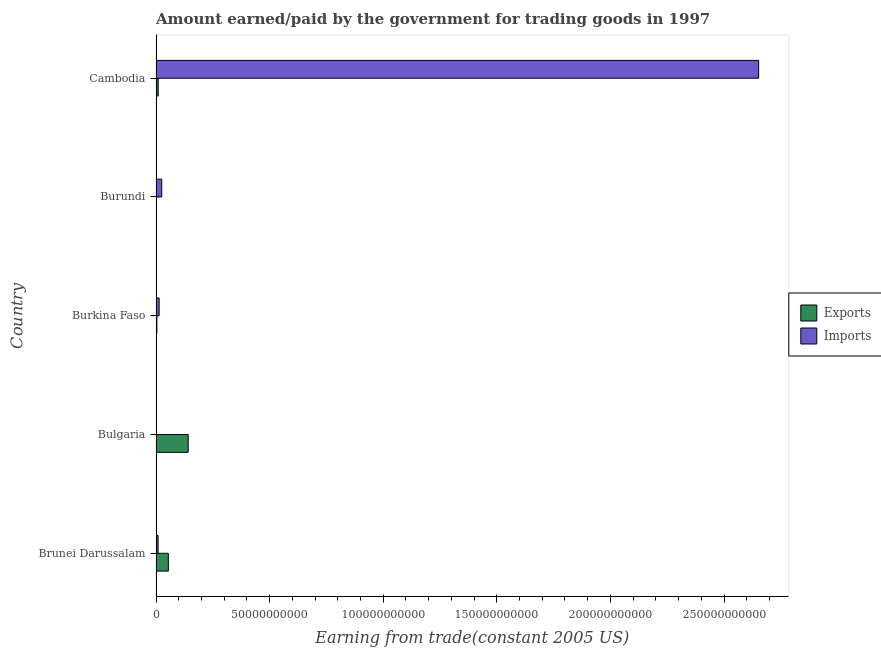How many different coloured bars are there?
Your answer should be very brief. 2. Are the number of bars on each tick of the Y-axis equal?
Give a very brief answer. Yes. What is the label of the 1st group of bars from the top?
Offer a terse response. Cambodia. What is the amount paid for imports in Brunei Darussalam?
Ensure brevity in your answer.  9.15e+08. Across all countries, what is the maximum amount paid for imports?
Your answer should be compact. 2.65e+11. Across all countries, what is the minimum amount paid for imports?
Offer a very short reply. 6.62e+07. In which country was the amount paid for imports maximum?
Make the answer very short. Cambodia. In which country was the amount earned from exports minimum?
Give a very brief answer. Burundi. What is the total amount paid for imports in the graph?
Offer a terse response. 2.70e+11. What is the difference between the amount earned from exports in Brunei Darussalam and that in Bulgaria?
Provide a short and direct response. -8.73e+09. What is the difference between the amount paid for imports in Burundi and the amount earned from exports in Brunei Darussalam?
Offer a terse response. -2.90e+09. What is the average amount paid for imports per country?
Keep it short and to the point. 5.40e+1. What is the difference between the amount earned from exports and amount paid for imports in Cambodia?
Your answer should be very brief. -2.64e+11. What is the ratio of the amount earned from exports in Burkina Faso to that in Burundi?
Give a very brief answer. 6.64. Is the amount paid for imports in Burundi less than that in Cambodia?
Offer a very short reply. Yes. Is the difference between the amount earned from exports in Bulgaria and Cambodia greater than the difference between the amount paid for imports in Bulgaria and Cambodia?
Offer a terse response. Yes. What is the difference between the highest and the second highest amount paid for imports?
Give a very brief answer. 2.63e+11. What is the difference between the highest and the lowest amount earned from exports?
Keep it short and to the point. 1.41e+1. Is the sum of the amount paid for imports in Bulgaria and Burkina Faso greater than the maximum amount earned from exports across all countries?
Keep it short and to the point. No. What does the 2nd bar from the top in Burkina Faso represents?
Give a very brief answer. Exports. What does the 2nd bar from the bottom in Burkina Faso represents?
Give a very brief answer. Imports. Are all the bars in the graph horizontal?
Your answer should be very brief. Yes. Does the graph contain any zero values?
Make the answer very short. No. How are the legend labels stacked?
Offer a terse response. Vertical. What is the title of the graph?
Your answer should be compact. Amount earned/paid by the government for trading goods in 1997. Does "Private credit bureau" appear as one of the legend labels in the graph?
Make the answer very short. No. What is the label or title of the X-axis?
Your answer should be compact. Earning from trade(constant 2005 US). What is the label or title of the Y-axis?
Provide a succinct answer. Country. What is the Earning from trade(constant 2005 US) in Exports in Brunei Darussalam?
Ensure brevity in your answer.  5.42e+09. What is the Earning from trade(constant 2005 US) of Imports in Brunei Darussalam?
Provide a short and direct response. 9.15e+08. What is the Earning from trade(constant 2005 US) of Exports in Bulgaria?
Provide a succinct answer. 1.42e+1. What is the Earning from trade(constant 2005 US) in Imports in Bulgaria?
Provide a short and direct response. 6.62e+07. What is the Earning from trade(constant 2005 US) of Exports in Burkina Faso?
Ensure brevity in your answer.  3.68e+08. What is the Earning from trade(constant 2005 US) in Imports in Burkina Faso?
Keep it short and to the point. 1.36e+09. What is the Earning from trade(constant 2005 US) of Exports in Burundi?
Your answer should be compact. 5.54e+07. What is the Earning from trade(constant 2005 US) in Imports in Burundi?
Your answer should be compact. 2.52e+09. What is the Earning from trade(constant 2005 US) of Exports in Cambodia?
Give a very brief answer. 9.76e+08. What is the Earning from trade(constant 2005 US) in Imports in Cambodia?
Your answer should be compact. 2.65e+11. Across all countries, what is the maximum Earning from trade(constant 2005 US) in Exports?
Keep it short and to the point. 1.42e+1. Across all countries, what is the maximum Earning from trade(constant 2005 US) in Imports?
Ensure brevity in your answer.  2.65e+11. Across all countries, what is the minimum Earning from trade(constant 2005 US) of Exports?
Your response must be concise. 5.54e+07. Across all countries, what is the minimum Earning from trade(constant 2005 US) of Imports?
Offer a very short reply. 6.62e+07. What is the total Earning from trade(constant 2005 US) in Exports in the graph?
Provide a succinct answer. 2.10e+1. What is the total Earning from trade(constant 2005 US) in Imports in the graph?
Keep it short and to the point. 2.70e+11. What is the difference between the Earning from trade(constant 2005 US) in Exports in Brunei Darussalam and that in Bulgaria?
Give a very brief answer. -8.73e+09. What is the difference between the Earning from trade(constant 2005 US) of Imports in Brunei Darussalam and that in Bulgaria?
Your answer should be very brief. 8.48e+08. What is the difference between the Earning from trade(constant 2005 US) of Exports in Brunei Darussalam and that in Burkina Faso?
Offer a terse response. 5.05e+09. What is the difference between the Earning from trade(constant 2005 US) of Imports in Brunei Darussalam and that in Burkina Faso?
Your answer should be very brief. -4.49e+08. What is the difference between the Earning from trade(constant 2005 US) in Exports in Brunei Darussalam and that in Burundi?
Provide a short and direct response. 5.37e+09. What is the difference between the Earning from trade(constant 2005 US) of Imports in Brunei Darussalam and that in Burundi?
Give a very brief answer. -1.60e+09. What is the difference between the Earning from trade(constant 2005 US) of Exports in Brunei Darussalam and that in Cambodia?
Your response must be concise. 4.45e+09. What is the difference between the Earning from trade(constant 2005 US) of Imports in Brunei Darussalam and that in Cambodia?
Keep it short and to the point. -2.64e+11. What is the difference between the Earning from trade(constant 2005 US) in Exports in Bulgaria and that in Burkina Faso?
Your answer should be very brief. 1.38e+1. What is the difference between the Earning from trade(constant 2005 US) of Imports in Bulgaria and that in Burkina Faso?
Keep it short and to the point. -1.30e+09. What is the difference between the Earning from trade(constant 2005 US) in Exports in Bulgaria and that in Burundi?
Make the answer very short. 1.41e+1. What is the difference between the Earning from trade(constant 2005 US) of Imports in Bulgaria and that in Burundi?
Provide a short and direct response. -2.45e+09. What is the difference between the Earning from trade(constant 2005 US) of Exports in Bulgaria and that in Cambodia?
Offer a terse response. 1.32e+1. What is the difference between the Earning from trade(constant 2005 US) in Imports in Bulgaria and that in Cambodia?
Your answer should be compact. -2.65e+11. What is the difference between the Earning from trade(constant 2005 US) of Exports in Burkina Faso and that in Burundi?
Your answer should be very brief. 3.12e+08. What is the difference between the Earning from trade(constant 2005 US) of Imports in Burkina Faso and that in Burundi?
Your answer should be compact. -1.16e+09. What is the difference between the Earning from trade(constant 2005 US) of Exports in Burkina Faso and that in Cambodia?
Provide a short and direct response. -6.09e+08. What is the difference between the Earning from trade(constant 2005 US) in Imports in Burkina Faso and that in Cambodia?
Your response must be concise. -2.64e+11. What is the difference between the Earning from trade(constant 2005 US) of Exports in Burundi and that in Cambodia?
Make the answer very short. -9.21e+08. What is the difference between the Earning from trade(constant 2005 US) of Imports in Burundi and that in Cambodia?
Provide a succinct answer. -2.63e+11. What is the difference between the Earning from trade(constant 2005 US) of Exports in Brunei Darussalam and the Earning from trade(constant 2005 US) of Imports in Bulgaria?
Give a very brief answer. 5.36e+09. What is the difference between the Earning from trade(constant 2005 US) in Exports in Brunei Darussalam and the Earning from trade(constant 2005 US) in Imports in Burkina Faso?
Your answer should be very brief. 4.06e+09. What is the difference between the Earning from trade(constant 2005 US) of Exports in Brunei Darussalam and the Earning from trade(constant 2005 US) of Imports in Burundi?
Keep it short and to the point. 2.90e+09. What is the difference between the Earning from trade(constant 2005 US) in Exports in Brunei Darussalam and the Earning from trade(constant 2005 US) in Imports in Cambodia?
Your answer should be very brief. -2.60e+11. What is the difference between the Earning from trade(constant 2005 US) of Exports in Bulgaria and the Earning from trade(constant 2005 US) of Imports in Burkina Faso?
Offer a terse response. 1.28e+1. What is the difference between the Earning from trade(constant 2005 US) in Exports in Bulgaria and the Earning from trade(constant 2005 US) in Imports in Burundi?
Give a very brief answer. 1.16e+1. What is the difference between the Earning from trade(constant 2005 US) in Exports in Bulgaria and the Earning from trade(constant 2005 US) in Imports in Cambodia?
Your response must be concise. -2.51e+11. What is the difference between the Earning from trade(constant 2005 US) in Exports in Burkina Faso and the Earning from trade(constant 2005 US) in Imports in Burundi?
Your answer should be very brief. -2.15e+09. What is the difference between the Earning from trade(constant 2005 US) of Exports in Burkina Faso and the Earning from trade(constant 2005 US) of Imports in Cambodia?
Your answer should be compact. -2.65e+11. What is the difference between the Earning from trade(constant 2005 US) in Exports in Burundi and the Earning from trade(constant 2005 US) in Imports in Cambodia?
Make the answer very short. -2.65e+11. What is the average Earning from trade(constant 2005 US) of Exports per country?
Give a very brief answer. 4.20e+09. What is the average Earning from trade(constant 2005 US) in Imports per country?
Offer a terse response. 5.40e+1. What is the difference between the Earning from trade(constant 2005 US) in Exports and Earning from trade(constant 2005 US) in Imports in Brunei Darussalam?
Provide a short and direct response. 4.51e+09. What is the difference between the Earning from trade(constant 2005 US) of Exports and Earning from trade(constant 2005 US) of Imports in Bulgaria?
Offer a very short reply. 1.41e+1. What is the difference between the Earning from trade(constant 2005 US) of Exports and Earning from trade(constant 2005 US) of Imports in Burkina Faso?
Offer a very short reply. -9.96e+08. What is the difference between the Earning from trade(constant 2005 US) of Exports and Earning from trade(constant 2005 US) of Imports in Burundi?
Your response must be concise. -2.46e+09. What is the difference between the Earning from trade(constant 2005 US) of Exports and Earning from trade(constant 2005 US) of Imports in Cambodia?
Keep it short and to the point. -2.64e+11. What is the ratio of the Earning from trade(constant 2005 US) in Exports in Brunei Darussalam to that in Bulgaria?
Offer a terse response. 0.38. What is the ratio of the Earning from trade(constant 2005 US) of Imports in Brunei Darussalam to that in Bulgaria?
Offer a very short reply. 13.82. What is the ratio of the Earning from trade(constant 2005 US) of Exports in Brunei Darussalam to that in Burkina Faso?
Offer a very short reply. 14.75. What is the ratio of the Earning from trade(constant 2005 US) in Imports in Brunei Darussalam to that in Burkina Faso?
Your answer should be compact. 0.67. What is the ratio of the Earning from trade(constant 2005 US) in Exports in Brunei Darussalam to that in Burundi?
Provide a succinct answer. 97.91. What is the ratio of the Earning from trade(constant 2005 US) in Imports in Brunei Darussalam to that in Burundi?
Give a very brief answer. 0.36. What is the ratio of the Earning from trade(constant 2005 US) in Exports in Brunei Darussalam to that in Cambodia?
Keep it short and to the point. 5.55. What is the ratio of the Earning from trade(constant 2005 US) in Imports in Brunei Darussalam to that in Cambodia?
Offer a very short reply. 0. What is the ratio of the Earning from trade(constant 2005 US) of Exports in Bulgaria to that in Burkina Faso?
Offer a very short reply. 38.52. What is the ratio of the Earning from trade(constant 2005 US) of Imports in Bulgaria to that in Burkina Faso?
Your response must be concise. 0.05. What is the ratio of the Earning from trade(constant 2005 US) of Exports in Bulgaria to that in Burundi?
Ensure brevity in your answer.  255.62. What is the ratio of the Earning from trade(constant 2005 US) of Imports in Bulgaria to that in Burundi?
Your answer should be very brief. 0.03. What is the ratio of the Earning from trade(constant 2005 US) in Exports in Bulgaria to that in Cambodia?
Provide a succinct answer. 14.5. What is the ratio of the Earning from trade(constant 2005 US) in Imports in Bulgaria to that in Cambodia?
Your answer should be very brief. 0. What is the ratio of the Earning from trade(constant 2005 US) in Exports in Burkina Faso to that in Burundi?
Offer a terse response. 6.64. What is the ratio of the Earning from trade(constant 2005 US) in Imports in Burkina Faso to that in Burundi?
Your answer should be very brief. 0.54. What is the ratio of the Earning from trade(constant 2005 US) in Exports in Burkina Faso to that in Cambodia?
Ensure brevity in your answer.  0.38. What is the ratio of the Earning from trade(constant 2005 US) in Imports in Burkina Faso to that in Cambodia?
Your answer should be compact. 0.01. What is the ratio of the Earning from trade(constant 2005 US) of Exports in Burundi to that in Cambodia?
Offer a terse response. 0.06. What is the ratio of the Earning from trade(constant 2005 US) in Imports in Burundi to that in Cambodia?
Provide a succinct answer. 0.01. What is the difference between the highest and the second highest Earning from trade(constant 2005 US) of Exports?
Ensure brevity in your answer.  8.73e+09. What is the difference between the highest and the second highest Earning from trade(constant 2005 US) of Imports?
Provide a short and direct response. 2.63e+11. What is the difference between the highest and the lowest Earning from trade(constant 2005 US) of Exports?
Your answer should be very brief. 1.41e+1. What is the difference between the highest and the lowest Earning from trade(constant 2005 US) of Imports?
Give a very brief answer. 2.65e+11. 